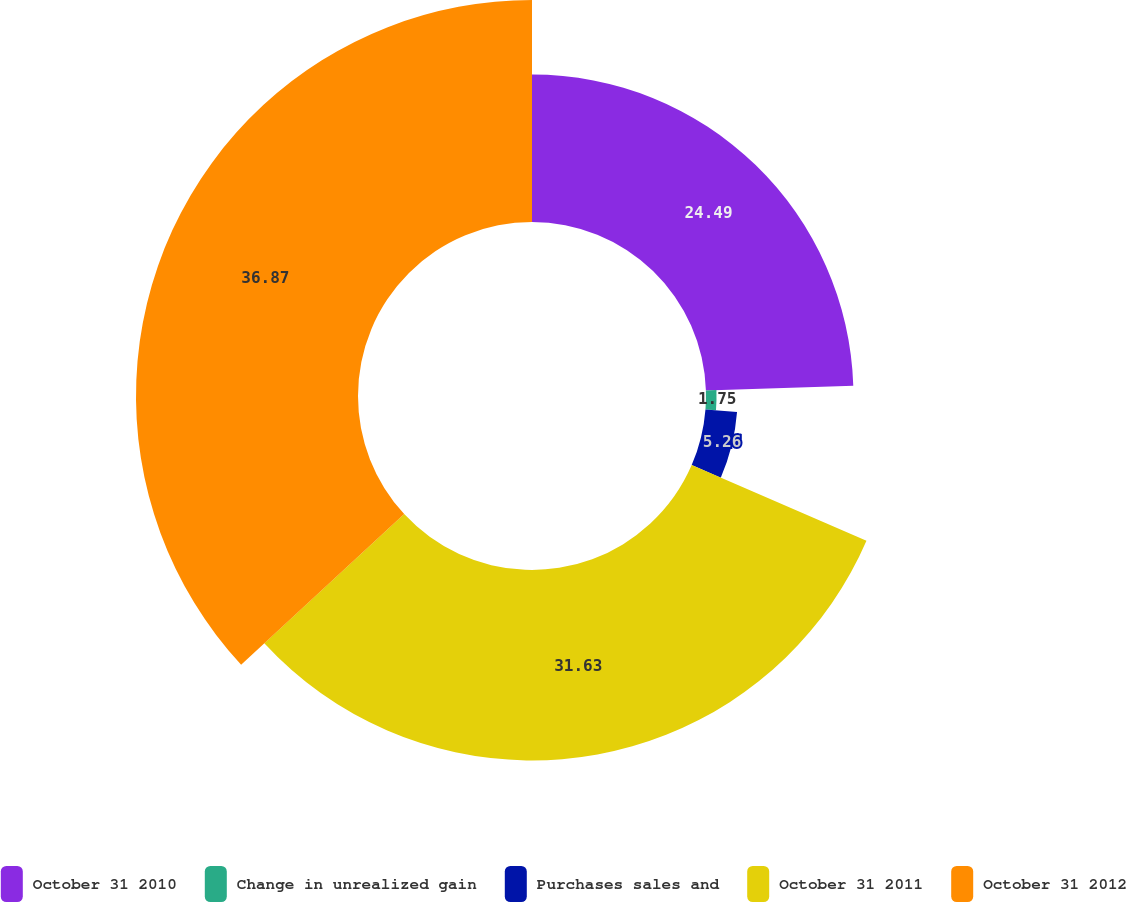Convert chart to OTSL. <chart><loc_0><loc_0><loc_500><loc_500><pie_chart><fcel>October 31 2010<fcel>Change in unrealized gain<fcel>Purchases sales and<fcel>October 31 2011<fcel>October 31 2012<nl><fcel>24.49%<fcel>1.75%<fcel>5.26%<fcel>31.63%<fcel>36.87%<nl></chart> 